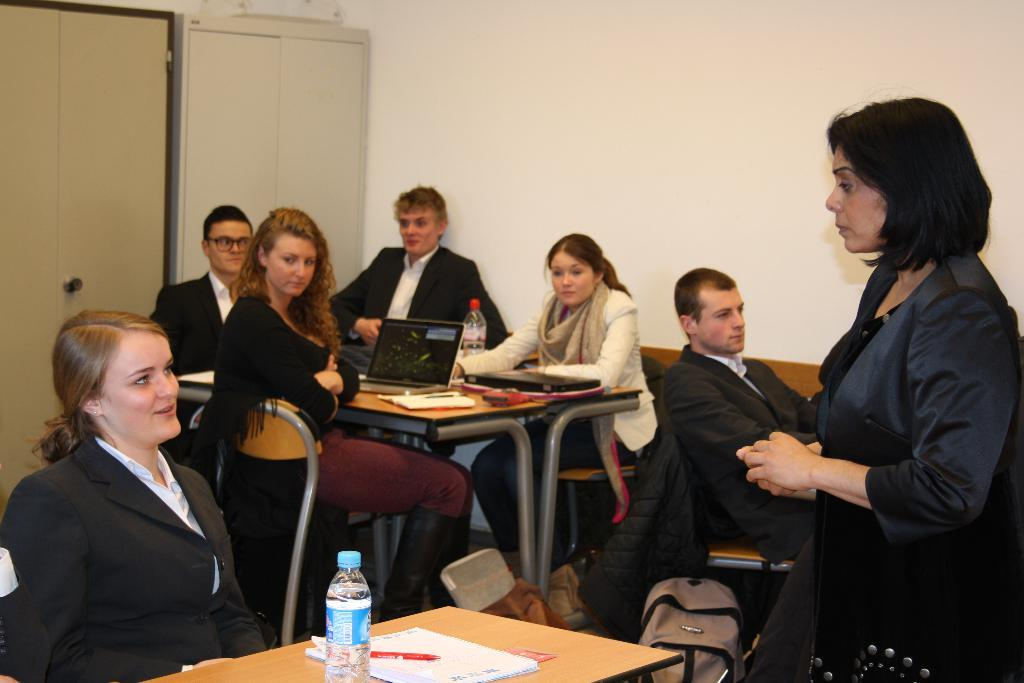What is the color of the wall in the image? The wall in the image is white. What can be seen in the image besides the wall? There is a camera, people sitting and standing on chairs, a table, a pen, a bottle, and a laptop visible in the image. What is the people's position in the image? The people are sitting and standing on chairs in the image. What is on the table in the image? There is a pen, a bottle, and a laptop on the table in the image. What type of scent can be smelled coming from the pipe in the image? There is no pipe present in the image, so it is not possible to determine what scent might be smelled. 